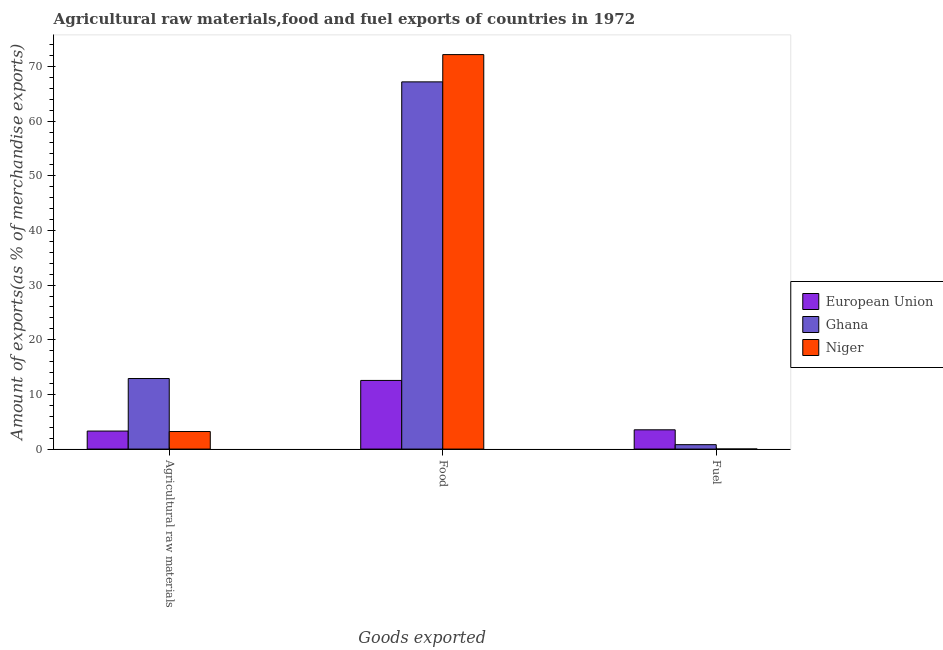Are the number of bars per tick equal to the number of legend labels?
Provide a short and direct response. Yes. Are the number of bars on each tick of the X-axis equal?
Offer a terse response. Yes. How many bars are there on the 1st tick from the left?
Your answer should be compact. 3. What is the label of the 2nd group of bars from the left?
Give a very brief answer. Food. What is the percentage of fuel exports in European Union?
Offer a terse response. 3.52. Across all countries, what is the maximum percentage of raw materials exports?
Provide a succinct answer. 12.91. Across all countries, what is the minimum percentage of raw materials exports?
Keep it short and to the point. 3.21. In which country was the percentage of raw materials exports maximum?
Offer a terse response. Ghana. In which country was the percentage of fuel exports minimum?
Give a very brief answer. Niger. What is the total percentage of raw materials exports in the graph?
Provide a succinct answer. 19.41. What is the difference between the percentage of fuel exports in European Union and that in Ghana?
Provide a succinct answer. 2.72. What is the difference between the percentage of food exports in Ghana and the percentage of raw materials exports in European Union?
Provide a succinct answer. 63.88. What is the average percentage of food exports per country?
Your answer should be very brief. 50.63. What is the difference between the percentage of food exports and percentage of raw materials exports in European Union?
Keep it short and to the point. 9.26. What is the ratio of the percentage of fuel exports in Ghana to that in Niger?
Your answer should be compact. 58.99. What is the difference between the highest and the second highest percentage of fuel exports?
Ensure brevity in your answer.  2.72. What is the difference between the highest and the lowest percentage of fuel exports?
Offer a very short reply. 3.51. In how many countries, is the percentage of raw materials exports greater than the average percentage of raw materials exports taken over all countries?
Provide a short and direct response. 1. What does the 3rd bar from the left in Fuel represents?
Your answer should be very brief. Niger. What does the 2nd bar from the right in Fuel represents?
Offer a terse response. Ghana. How many countries are there in the graph?
Provide a short and direct response. 3. What is the difference between two consecutive major ticks on the Y-axis?
Keep it short and to the point. 10. Does the graph contain any zero values?
Provide a short and direct response. No. Does the graph contain grids?
Provide a short and direct response. No. Where does the legend appear in the graph?
Your response must be concise. Center right. How many legend labels are there?
Give a very brief answer. 3. What is the title of the graph?
Provide a short and direct response. Agricultural raw materials,food and fuel exports of countries in 1972. Does "Dominica" appear as one of the legend labels in the graph?
Your response must be concise. No. What is the label or title of the X-axis?
Make the answer very short. Goods exported. What is the label or title of the Y-axis?
Provide a succinct answer. Amount of exports(as % of merchandise exports). What is the Amount of exports(as % of merchandise exports) in European Union in Agricultural raw materials?
Make the answer very short. 3.3. What is the Amount of exports(as % of merchandise exports) of Ghana in Agricultural raw materials?
Keep it short and to the point. 12.91. What is the Amount of exports(as % of merchandise exports) of Niger in Agricultural raw materials?
Provide a short and direct response. 3.21. What is the Amount of exports(as % of merchandise exports) of European Union in Food?
Make the answer very short. 12.56. What is the Amount of exports(as % of merchandise exports) of Ghana in Food?
Offer a terse response. 67.18. What is the Amount of exports(as % of merchandise exports) of Niger in Food?
Your answer should be very brief. 72.17. What is the Amount of exports(as % of merchandise exports) of European Union in Fuel?
Provide a short and direct response. 3.52. What is the Amount of exports(as % of merchandise exports) in Ghana in Fuel?
Your answer should be compact. 0.81. What is the Amount of exports(as % of merchandise exports) in Niger in Fuel?
Give a very brief answer. 0.01. Across all Goods exported, what is the maximum Amount of exports(as % of merchandise exports) in European Union?
Provide a succinct answer. 12.56. Across all Goods exported, what is the maximum Amount of exports(as % of merchandise exports) in Ghana?
Give a very brief answer. 67.18. Across all Goods exported, what is the maximum Amount of exports(as % of merchandise exports) in Niger?
Provide a short and direct response. 72.17. Across all Goods exported, what is the minimum Amount of exports(as % of merchandise exports) in European Union?
Your response must be concise. 3.3. Across all Goods exported, what is the minimum Amount of exports(as % of merchandise exports) in Ghana?
Your answer should be compact. 0.81. Across all Goods exported, what is the minimum Amount of exports(as % of merchandise exports) of Niger?
Your answer should be very brief. 0.01. What is the total Amount of exports(as % of merchandise exports) of European Union in the graph?
Keep it short and to the point. 19.38. What is the total Amount of exports(as % of merchandise exports) in Ghana in the graph?
Your answer should be compact. 80.89. What is the total Amount of exports(as % of merchandise exports) of Niger in the graph?
Offer a very short reply. 75.39. What is the difference between the Amount of exports(as % of merchandise exports) in European Union in Agricultural raw materials and that in Food?
Your answer should be compact. -9.26. What is the difference between the Amount of exports(as % of merchandise exports) of Ghana in Agricultural raw materials and that in Food?
Keep it short and to the point. -54.27. What is the difference between the Amount of exports(as % of merchandise exports) of Niger in Agricultural raw materials and that in Food?
Your response must be concise. -68.96. What is the difference between the Amount of exports(as % of merchandise exports) in European Union in Agricultural raw materials and that in Fuel?
Your answer should be compact. -0.23. What is the difference between the Amount of exports(as % of merchandise exports) of Ghana in Agricultural raw materials and that in Fuel?
Offer a terse response. 12.1. What is the difference between the Amount of exports(as % of merchandise exports) in Niger in Agricultural raw materials and that in Fuel?
Your answer should be very brief. 3.2. What is the difference between the Amount of exports(as % of merchandise exports) of European Union in Food and that in Fuel?
Provide a succinct answer. 9.03. What is the difference between the Amount of exports(as % of merchandise exports) of Ghana in Food and that in Fuel?
Provide a short and direct response. 66.37. What is the difference between the Amount of exports(as % of merchandise exports) of Niger in Food and that in Fuel?
Offer a terse response. 72.15. What is the difference between the Amount of exports(as % of merchandise exports) of European Union in Agricultural raw materials and the Amount of exports(as % of merchandise exports) of Ghana in Food?
Provide a short and direct response. -63.88. What is the difference between the Amount of exports(as % of merchandise exports) of European Union in Agricultural raw materials and the Amount of exports(as % of merchandise exports) of Niger in Food?
Give a very brief answer. -68.87. What is the difference between the Amount of exports(as % of merchandise exports) in Ghana in Agricultural raw materials and the Amount of exports(as % of merchandise exports) in Niger in Food?
Your response must be concise. -59.26. What is the difference between the Amount of exports(as % of merchandise exports) in European Union in Agricultural raw materials and the Amount of exports(as % of merchandise exports) in Ghana in Fuel?
Offer a very short reply. 2.49. What is the difference between the Amount of exports(as % of merchandise exports) of European Union in Agricultural raw materials and the Amount of exports(as % of merchandise exports) of Niger in Fuel?
Make the answer very short. 3.28. What is the difference between the Amount of exports(as % of merchandise exports) in Ghana in Agricultural raw materials and the Amount of exports(as % of merchandise exports) in Niger in Fuel?
Ensure brevity in your answer.  12.89. What is the difference between the Amount of exports(as % of merchandise exports) in European Union in Food and the Amount of exports(as % of merchandise exports) in Ghana in Fuel?
Your response must be concise. 11.75. What is the difference between the Amount of exports(as % of merchandise exports) in European Union in Food and the Amount of exports(as % of merchandise exports) in Niger in Fuel?
Your answer should be compact. 12.54. What is the difference between the Amount of exports(as % of merchandise exports) of Ghana in Food and the Amount of exports(as % of merchandise exports) of Niger in Fuel?
Give a very brief answer. 67.16. What is the average Amount of exports(as % of merchandise exports) of European Union per Goods exported?
Your answer should be compact. 6.46. What is the average Amount of exports(as % of merchandise exports) of Ghana per Goods exported?
Your answer should be compact. 26.96. What is the average Amount of exports(as % of merchandise exports) in Niger per Goods exported?
Offer a terse response. 25.13. What is the difference between the Amount of exports(as % of merchandise exports) of European Union and Amount of exports(as % of merchandise exports) of Ghana in Agricultural raw materials?
Provide a succinct answer. -9.61. What is the difference between the Amount of exports(as % of merchandise exports) of European Union and Amount of exports(as % of merchandise exports) of Niger in Agricultural raw materials?
Your answer should be compact. 0.09. What is the difference between the Amount of exports(as % of merchandise exports) in Ghana and Amount of exports(as % of merchandise exports) in Niger in Agricultural raw materials?
Your response must be concise. 9.7. What is the difference between the Amount of exports(as % of merchandise exports) of European Union and Amount of exports(as % of merchandise exports) of Ghana in Food?
Make the answer very short. -54.62. What is the difference between the Amount of exports(as % of merchandise exports) in European Union and Amount of exports(as % of merchandise exports) in Niger in Food?
Offer a very short reply. -59.61. What is the difference between the Amount of exports(as % of merchandise exports) in Ghana and Amount of exports(as % of merchandise exports) in Niger in Food?
Your response must be concise. -4.99. What is the difference between the Amount of exports(as % of merchandise exports) in European Union and Amount of exports(as % of merchandise exports) in Ghana in Fuel?
Provide a short and direct response. 2.72. What is the difference between the Amount of exports(as % of merchandise exports) in European Union and Amount of exports(as % of merchandise exports) in Niger in Fuel?
Your answer should be very brief. 3.51. What is the difference between the Amount of exports(as % of merchandise exports) in Ghana and Amount of exports(as % of merchandise exports) in Niger in Fuel?
Offer a very short reply. 0.79. What is the ratio of the Amount of exports(as % of merchandise exports) of European Union in Agricultural raw materials to that in Food?
Offer a very short reply. 0.26. What is the ratio of the Amount of exports(as % of merchandise exports) of Ghana in Agricultural raw materials to that in Food?
Provide a short and direct response. 0.19. What is the ratio of the Amount of exports(as % of merchandise exports) in Niger in Agricultural raw materials to that in Food?
Provide a succinct answer. 0.04. What is the ratio of the Amount of exports(as % of merchandise exports) of European Union in Agricultural raw materials to that in Fuel?
Make the answer very short. 0.94. What is the ratio of the Amount of exports(as % of merchandise exports) of Ghana in Agricultural raw materials to that in Fuel?
Ensure brevity in your answer.  15.98. What is the ratio of the Amount of exports(as % of merchandise exports) in Niger in Agricultural raw materials to that in Fuel?
Your answer should be very brief. 234.43. What is the ratio of the Amount of exports(as % of merchandise exports) in European Union in Food to that in Fuel?
Provide a succinct answer. 3.56. What is the ratio of the Amount of exports(as % of merchandise exports) in Ghana in Food to that in Fuel?
Provide a short and direct response. 83.16. What is the ratio of the Amount of exports(as % of merchandise exports) in Niger in Food to that in Fuel?
Provide a succinct answer. 5270.4. What is the difference between the highest and the second highest Amount of exports(as % of merchandise exports) in European Union?
Make the answer very short. 9.03. What is the difference between the highest and the second highest Amount of exports(as % of merchandise exports) in Ghana?
Your answer should be very brief. 54.27. What is the difference between the highest and the second highest Amount of exports(as % of merchandise exports) in Niger?
Provide a succinct answer. 68.96. What is the difference between the highest and the lowest Amount of exports(as % of merchandise exports) in European Union?
Give a very brief answer. 9.26. What is the difference between the highest and the lowest Amount of exports(as % of merchandise exports) of Ghana?
Keep it short and to the point. 66.37. What is the difference between the highest and the lowest Amount of exports(as % of merchandise exports) in Niger?
Your response must be concise. 72.15. 